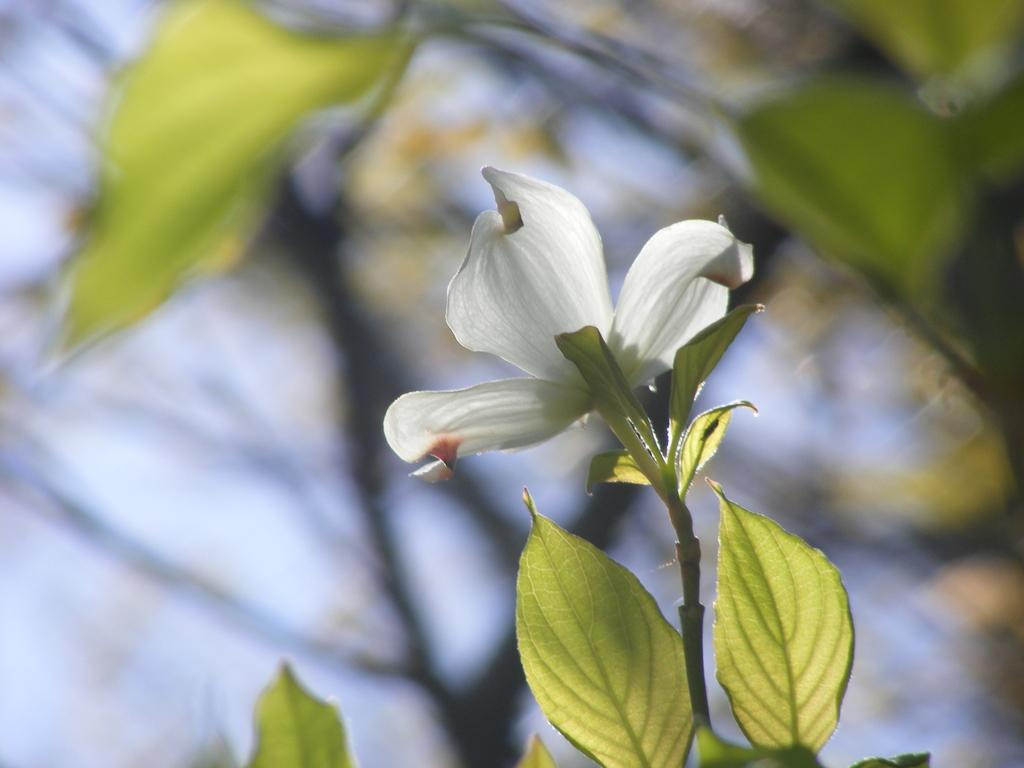What type of flower is in the image? There is a white flower in the image. Can you describe the flower's structure? The flower has a stem and leaves. What is the background of the image like? The background of the image has a blurred view. Are there any other leaves visible in the image besides the flower's leaves? Yes, there are leaves visible in the image. What type of linen can be seen draped over the cannon in the image? There is no cannon or linen present in the image; it features a white flower with a stem and leaves, and a blurred background. 